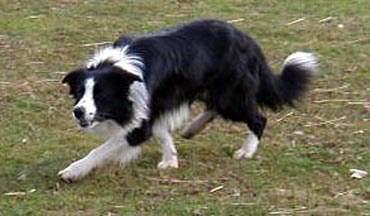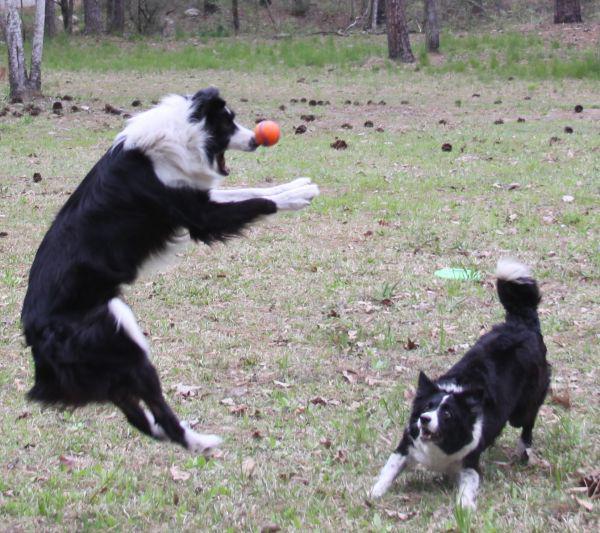The first image is the image on the left, the second image is the image on the right. For the images shown, is this caption "There are two dogs in the image on the right" true? Answer yes or no. Yes. The first image is the image on the left, the second image is the image on the right. Evaluate the accuracy of this statement regarding the images: "A dog has at least one paw in the air.". Is it true? Answer yes or no. Yes. 